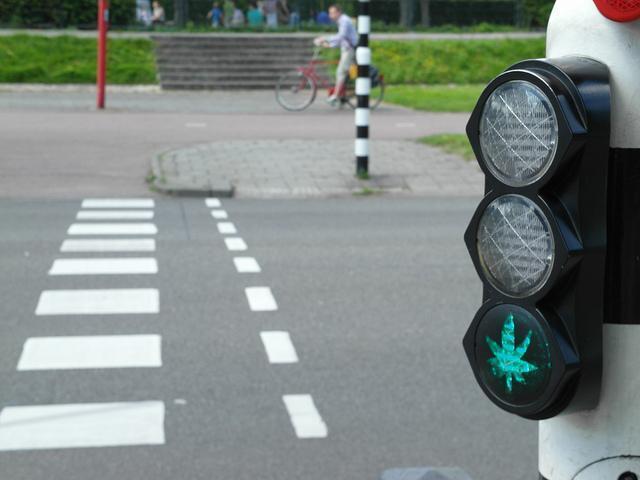How many oranges have stickers on them?
Give a very brief answer. 0. 